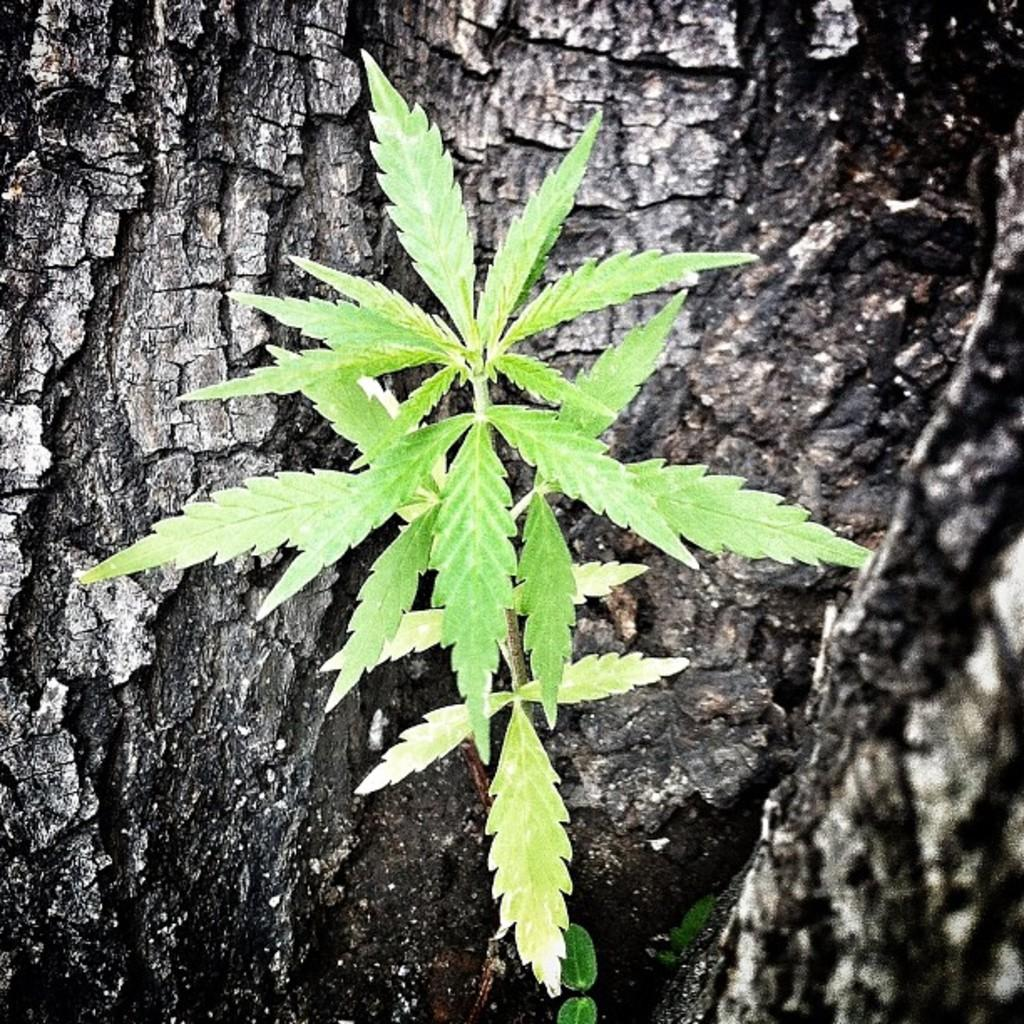Where was the image taken? The image was taken outdoors. What can be seen in the image besides the outdoor setting? There is a tree in the image. What are the characteristics of the tree in the image? The tree has leaves, stems, and a branch. What type of rhythm can be heard coming from the tree in the image? There is no sound or rhythm associated with the tree in the image. 